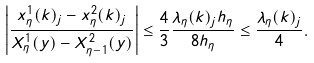Convert formula to latex. <formula><loc_0><loc_0><loc_500><loc_500>\left | \frac { x ^ { 1 } _ { \eta } ( k ) _ { j } - x ^ { 2 } _ { \eta } ( k ) _ { j } } { X ^ { 1 } _ { \eta } ( y ) - X ^ { 2 } _ { \eta - 1 } ( y ) } \right | \leq \frac { 4 } { 3 } \frac { \lambda _ { \eta } ( k ) _ { j } h _ { \eta } } { 8 h _ { \eta } } \leq \frac { \lambda _ { \eta } ( k ) _ { j } } { 4 } .</formula> 